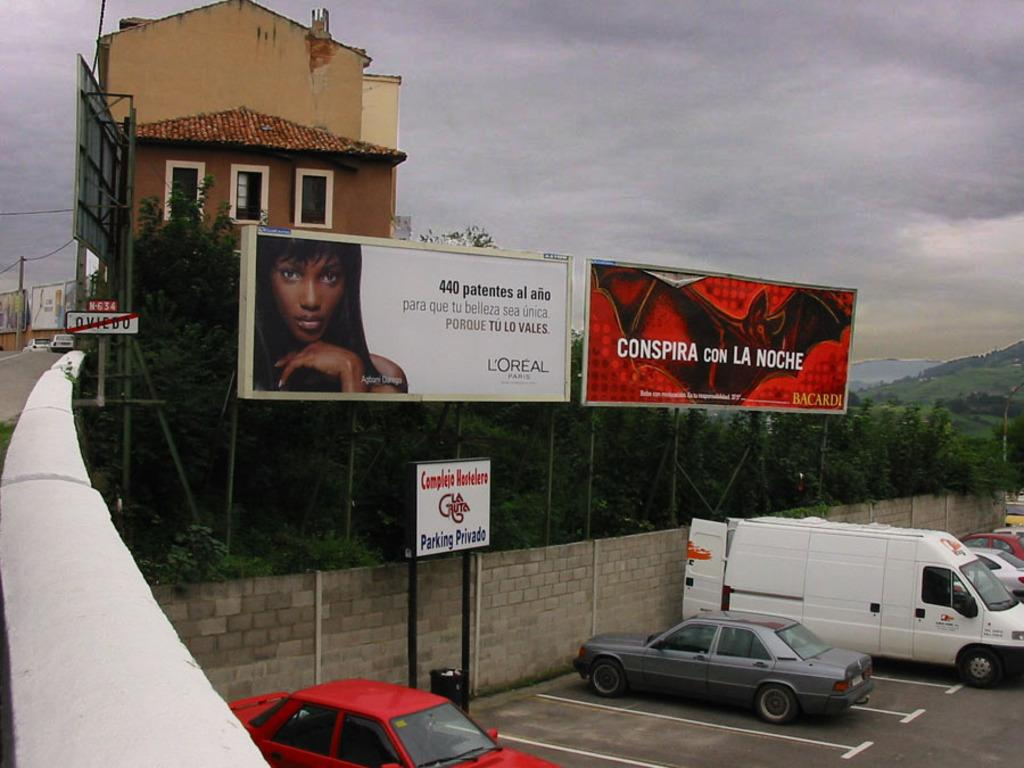<image>
Create a compact narrative representing the image presented. A parking sign reads parking privado in front of an empty space. 